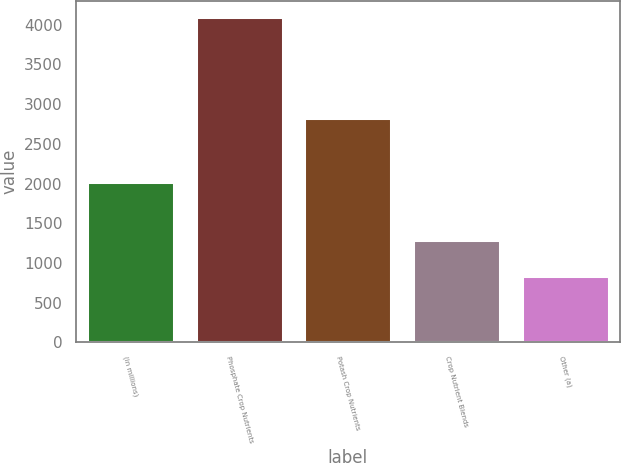Convert chart to OTSL. <chart><loc_0><loc_0><loc_500><loc_500><bar_chart><fcel>(in millions)<fcel>Phosphate Crop Nutrients<fcel>Potash Crop Nutrients<fcel>Crop Nutrient Blends<fcel>Other (a)<nl><fcel>2014<fcel>4096.2<fcel>2828.8<fcel>1292.9<fcel>837.9<nl></chart> 